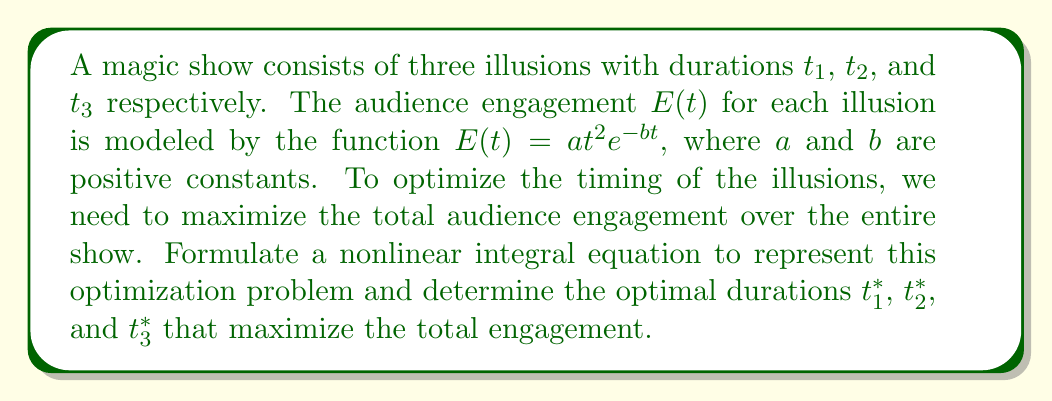Help me with this question. 1) First, we formulate the total engagement for the show as the sum of engagements for each illusion:

   $$\text{Total Engagement} = \int_0^{t_1} at^2e^{-bt}dt + \int_0^{t_2} at^2e^{-bt}dt + \int_0^{t_3} at^2e^{-bt}dt$$

2) Our goal is to maximize this total engagement subject to a total time constraint $T$:

   $$t_1 + t_2 + t_3 = T$$

3) This forms a constrained optimization problem. We can use the method of Lagrange multipliers to solve it.

4) Let's define the Lagrangian function:

   $$L(t_1, t_2, t_3, \lambda) = \int_0^{t_1} at^2e^{-bt}dt + \int_0^{t_2} at^2e^{-bt}dt + \int_0^{t_3} at^2e^{-bt}dt + \lambda(T - t_1 - t_2 - t_3)$$

5) For optimality, we need to set the partial derivatives of $L$ with respect to $t_1$, $t_2$, $t_3$, and $\lambda$ to zero:

   $$\frac{\partial L}{\partial t_1} = at_1^2e^{-bt_1} - \lambda = 0$$
   $$\frac{\partial L}{\partial t_2} = at_2^2e^{-bt_2} - \lambda = 0$$
   $$\frac{\partial L}{\partial t_3} = at_3^2e^{-bt_3} - \lambda = 0$$
   $$\frac{\partial L}{\partial \lambda} = T - t_1 - t_2 - t_3 = 0$$

6) From the first three equations, we can see that:

   $$t_1^2e^{-bt_1} = t_2^2e^{-bt_2} = t_3^2e^{-bt_3}$$

7) This implies that $t_1 = t_2 = t_3$. Let's call this common value $t^*$.

8) From the constraint equation, we can conclude:

   $$3t^* = T$$
   $$t^* = \frac{T}{3}$$

9) Therefore, the optimal durations for each illusion are:

   $$t_1^* = t_2^* = t_3^* = \frac{T}{3}$$
Answer: $t_1^* = t_2^* = t_3^* = \frac{T}{3}$ 